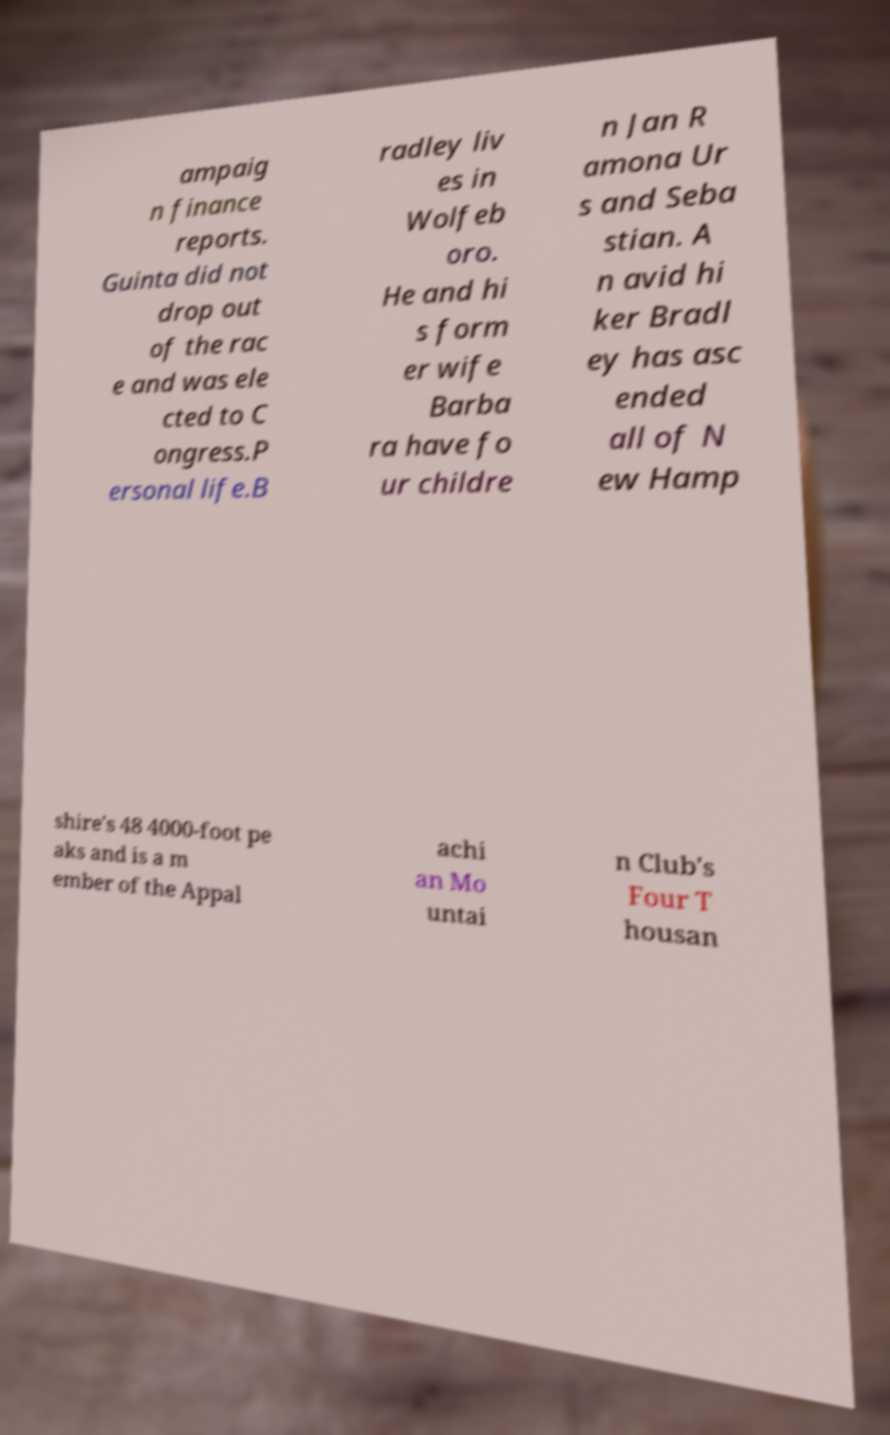Can you accurately transcribe the text from the provided image for me? ampaig n finance reports. Guinta did not drop out of the rac e and was ele cted to C ongress.P ersonal life.B radley liv es in Wolfeb oro. He and hi s form er wife Barba ra have fo ur childre n Jan R amona Ur s and Seba stian. A n avid hi ker Bradl ey has asc ended all of N ew Hamp shire's 48 4000-foot pe aks and is a m ember of the Appal achi an Mo untai n Club's Four T housan 